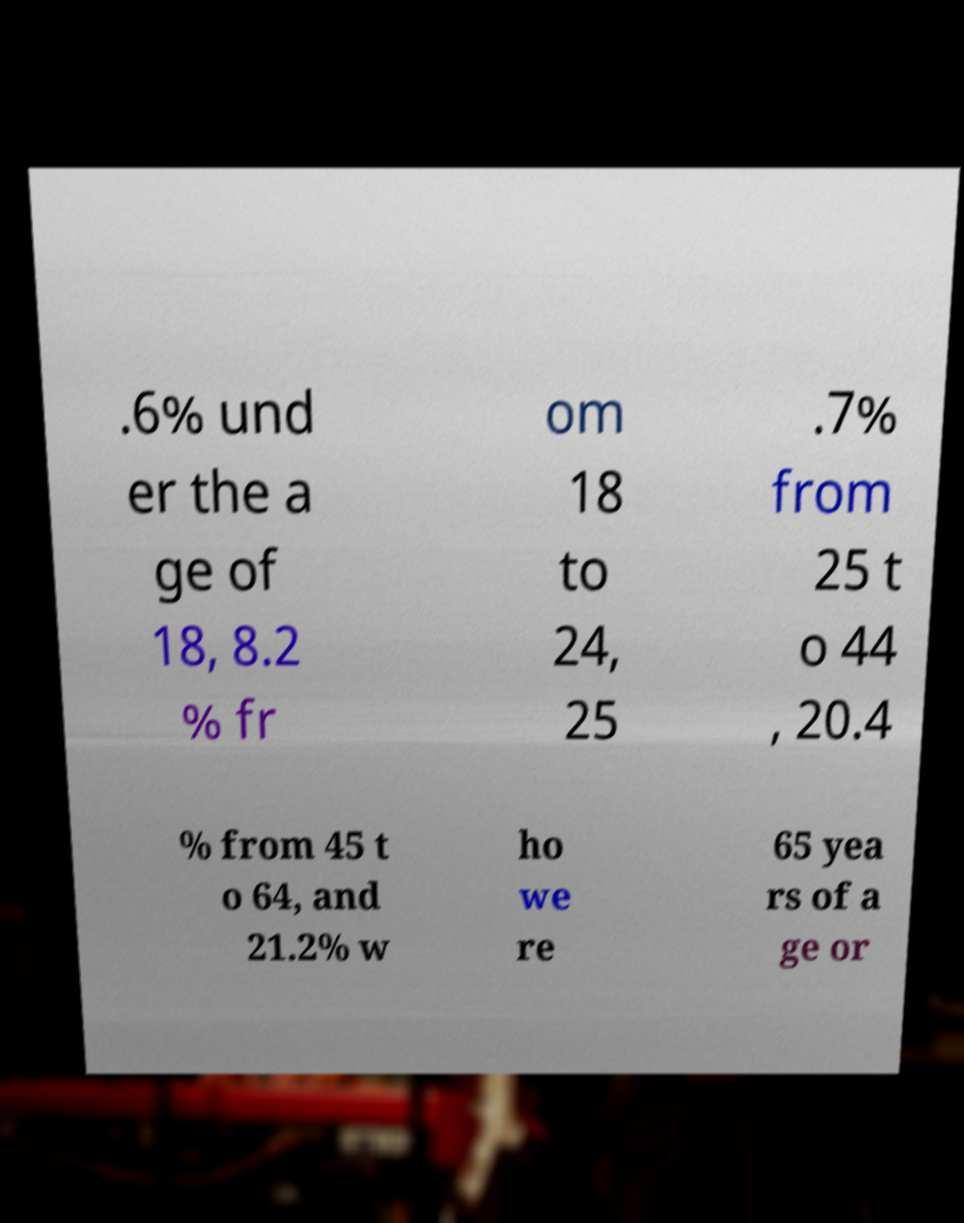I need the written content from this picture converted into text. Can you do that? .6% und er the a ge of 18, 8.2 % fr om 18 to 24, 25 .7% from 25 t o 44 , 20.4 % from 45 t o 64, and 21.2% w ho we re 65 yea rs of a ge or 